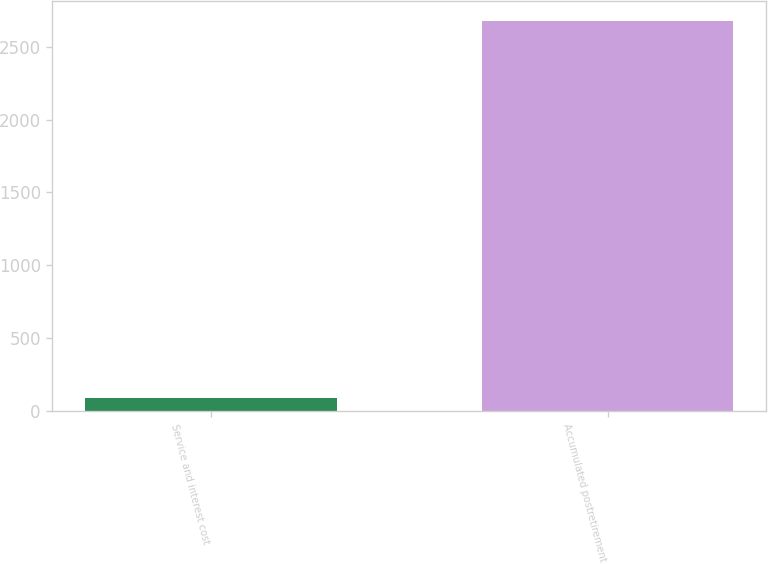Convert chart. <chart><loc_0><loc_0><loc_500><loc_500><bar_chart><fcel>Service and interest cost<fcel>Accumulated postretirement<nl><fcel>88<fcel>2678<nl></chart> 